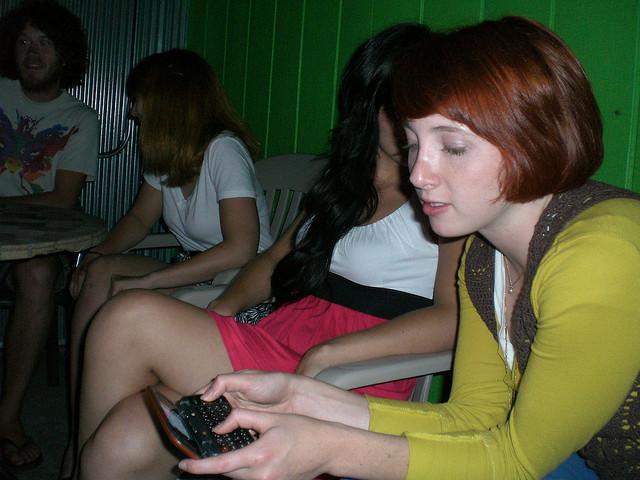What game are they playing?
Concise answer only. Video. On what are they sitting?
Answer briefly. Chairs. Does the woman's shirt have sleeves?
Concise answer only. Yes. Is the woman making anybody wait for her?
Keep it brief. No. How could the woman in green tell time quickly?
Give a very brief answer. Phone. Which girl has red hair?
Keep it brief. Right. What is the woman on the right holding?
Keep it brief. Phone. Is this woman missing her shirt?
Give a very brief answer. No. What is she  holding?
Answer briefly. Phone. Is the girl asleep?
Keep it brief. No. What is pink that the young lady has on?
Concise answer only. Skirt. What is the girl reaching into?
Write a very short answer. Phone. What game system is he playing on?
Quick response, please. Phone. How many people are in this photo?
Write a very short answer. 4. Is the person a young adult or elderly adult?
Quick response, please. Young. Is this woman wearing eye makeup?
Short answer required. No. What game system is she playing with?
Write a very short answer. Cell phone. How many arms are in view?
Concise answer only. 7. How many people are in the photo?
Be succinct. 4. What is in her hand?
Write a very short answer. Phone. What is the phone doing?
Give a very brief answer. Texting. What are the children looking at?
Concise answer only. Cell phone. What gaming console are they using?
Concise answer only. Phone. What color is the woman's dress?
Be succinct. Pink. Is the woman wearing eye makeup?
Quick response, please. No. What electrical appliance is the woman using?
Write a very short answer. Phone. Is the image blurry in some places?
Write a very short answer. No. What color are the eyes of the girl in glasses?
Keep it brief. Unknown. What game system is she playing?
Give a very brief answer. Phone. Is the woman wearing a wristwatch?
Be succinct. No. What is the girl seated on?
Short answer required. Chair. 